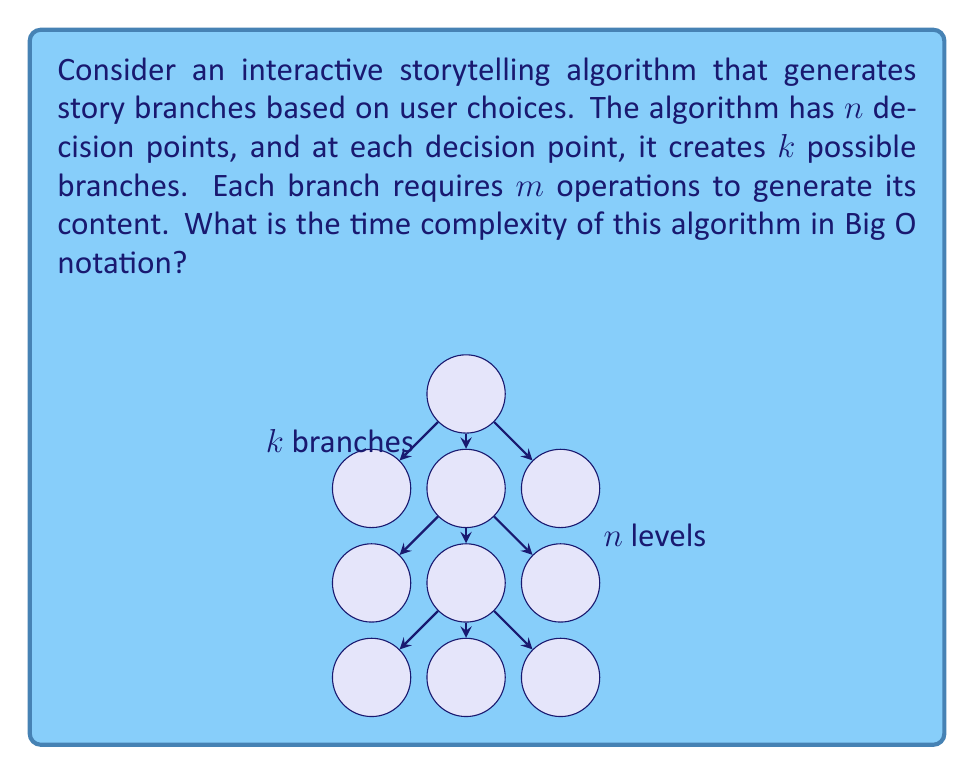Solve this math problem. Let's analyze this algorithm step-by-step:

1) At each decision point, the algorithm creates $k$ branches.

2) There are $n$ decision points in total.

3) For each branch, $m$ operations are performed to generate content.

4) At the first decision point, we have $k$ branches.

5) At the second decision point, each of the $k$ branches from the first point creates $k$ new branches, resulting in $k^2$ branches.

6) This pattern continues for all $n$ decision points.

7) The total number of branches after $n$ decision points is:

   $k + k^2 + k^3 + ... + k^n = \sum_{i=1}^n k^i$

8) This is a geometric series with $n$ terms, first term $a=k$, and common ratio $r=k$. The sum of this series is given by:

   $S_n = \frac{a(1-r^n)}{1-r} = \frac{k(1-k^n)}{1-k} = k\frac{k^n-1}{k-1}$

9) For large $n$, this is dominated by $k^n$.

10) For each of these branches, we perform $m$ operations.

11) Therefore, the total number of operations is $O(m \cdot k^n)$.

Since $m$ is constant for each branch, the time complexity is dominated by the exponential growth of branches.
Answer: $O(k^n)$ 